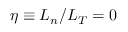<formula> <loc_0><loc_0><loc_500><loc_500>\eta \equiv L _ { n } / L _ { T } = 0</formula> 